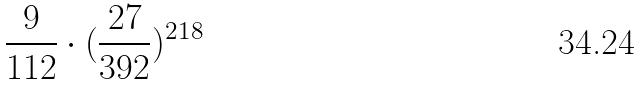<formula> <loc_0><loc_0><loc_500><loc_500>\frac { 9 } { 1 1 2 } \cdot ( \frac { 2 7 } { 3 9 2 } ) ^ { 2 1 8 }</formula> 